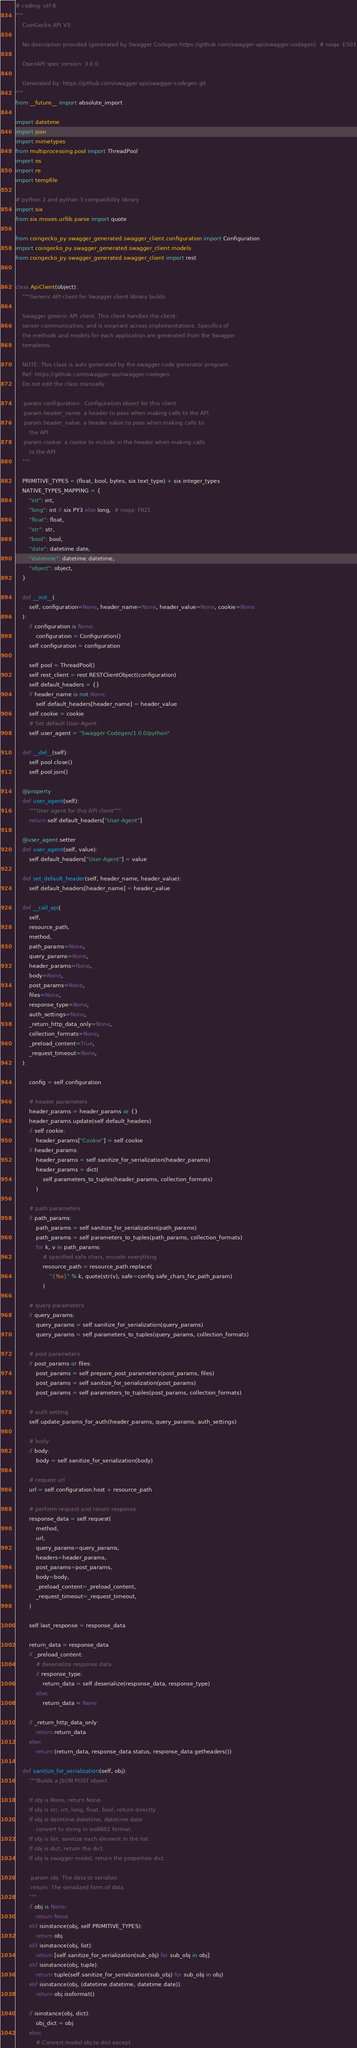<code> <loc_0><loc_0><loc_500><loc_500><_Python_># coding: utf-8
"""
    CoinGecko API V3

    No description provided (generated by Swagger Codegen https://github.com/swagger-api/swagger-codegen)  # noqa: E501

    OpenAPI spec version: 3.0.0
    
    Generated by: https://github.com/swagger-api/swagger-codegen.git
"""
from __future__ import absolute_import

import datetime
import json
import mimetypes
from multiprocessing.pool import ThreadPool
import os
import re
import tempfile

# python 2 and python 3 compatibility library
import six
from six.moves.urllib.parse import quote

from coingecko_py.swagger_generated.swagger_client.configuration import Configuration
import coingecko_py.swagger_generated.swagger_client.models
from coingecko_py.swagger_generated.swagger_client import rest


class ApiClient(object):
    """Generic API client for Swagger client library builds.

    Swagger generic API client. This client handles the client-
    server communication, and is invariant across implementations. Specifics of
    the methods and models for each application are generated from the Swagger
    templates.

    NOTE: This class is auto generated by the swagger code generator program.
    Ref: https://github.com/swagger-api/swagger-codegen
    Do not edit the class manually.

    :param configuration: .Configuration object for this client
    :param header_name: a header to pass when making calls to the API.
    :param header_value: a header value to pass when making calls to
        the API.
    :param cookie: a cookie to include in the header when making calls
        to the API
    """

    PRIMITIVE_TYPES = (float, bool, bytes, six.text_type) + six.integer_types
    NATIVE_TYPES_MAPPING = {
        "int": int,
        "long": int if six.PY3 else long,  # noqa: F821
        "float": float,
        "str": str,
        "bool": bool,
        "date": datetime.date,
        "datetime": datetime.datetime,
        "object": object,
    }

    def __init__(
        self, configuration=None, header_name=None, header_value=None, cookie=None
    ):
        if configuration is None:
            configuration = Configuration()
        self.configuration = configuration

        self.pool = ThreadPool()
        self.rest_client = rest.RESTClientObject(configuration)
        self.default_headers = {}
        if header_name is not None:
            self.default_headers[header_name] = header_value
        self.cookie = cookie
        # Set default User-Agent.
        self.user_agent = "Swagger-Codegen/1.0.0/python"

    def __del__(self):
        self.pool.close()
        self.pool.join()

    @property
    def user_agent(self):
        """User agent for this API client"""
        return self.default_headers["User-Agent"]

    @user_agent.setter
    def user_agent(self, value):
        self.default_headers["User-Agent"] = value

    def set_default_header(self, header_name, header_value):
        self.default_headers[header_name] = header_value

    def __call_api(
        self,
        resource_path,
        method,
        path_params=None,
        query_params=None,
        header_params=None,
        body=None,
        post_params=None,
        files=None,
        response_type=None,
        auth_settings=None,
        _return_http_data_only=None,
        collection_formats=None,
        _preload_content=True,
        _request_timeout=None,
    ):

        config = self.configuration

        # header parameters
        header_params = header_params or {}
        header_params.update(self.default_headers)
        if self.cookie:
            header_params["Cookie"] = self.cookie
        if header_params:
            header_params = self.sanitize_for_serialization(header_params)
            header_params = dict(
                self.parameters_to_tuples(header_params, collection_formats)
            )

        # path parameters
        if path_params:
            path_params = self.sanitize_for_serialization(path_params)
            path_params = self.parameters_to_tuples(path_params, collection_formats)
            for k, v in path_params:
                # specified safe chars, encode everything
                resource_path = resource_path.replace(
                    "{%s}" % k, quote(str(v), safe=config.safe_chars_for_path_param)
                )

        # query parameters
        if query_params:
            query_params = self.sanitize_for_serialization(query_params)
            query_params = self.parameters_to_tuples(query_params, collection_formats)

        # post parameters
        if post_params or files:
            post_params = self.prepare_post_parameters(post_params, files)
            post_params = self.sanitize_for_serialization(post_params)
            post_params = self.parameters_to_tuples(post_params, collection_formats)

        # auth setting
        self.update_params_for_auth(header_params, query_params, auth_settings)

        # body
        if body:
            body = self.sanitize_for_serialization(body)

        # request url
        url = self.configuration.host + resource_path

        # perform request and return response
        response_data = self.request(
            method,
            url,
            query_params=query_params,
            headers=header_params,
            post_params=post_params,
            body=body,
            _preload_content=_preload_content,
            _request_timeout=_request_timeout,
        )

        self.last_response = response_data

        return_data = response_data
        if _preload_content:
            # deserialize response data
            if response_type:
                return_data = self.deserialize(response_data, response_type)
            else:
                return_data = None

        if _return_http_data_only:
            return return_data
        else:
            return (return_data, response_data.status, response_data.getheaders())

    def sanitize_for_serialization(self, obj):
        """Builds a JSON POST object.

        If obj is None, return None.
        If obj is str, int, long, float, bool, return directly.
        If obj is datetime.datetime, datetime.date
            convert to string in iso8601 format.
        If obj is list, sanitize each element in the list.
        If obj is dict, return the dict.
        If obj is swagger model, return the properties dict.

        :param obj: The data to serialize.
        :return: The serialized form of data.
        """
        if obj is None:
            return None
        elif isinstance(obj, self.PRIMITIVE_TYPES):
            return obj
        elif isinstance(obj, list):
            return [self.sanitize_for_serialization(sub_obj) for sub_obj in obj]
        elif isinstance(obj, tuple):
            return tuple(self.sanitize_for_serialization(sub_obj) for sub_obj in obj)
        elif isinstance(obj, (datetime.datetime, datetime.date)):
            return obj.isoformat()

        if isinstance(obj, dict):
            obj_dict = obj
        else:
            # Convert model obj to dict except</code> 